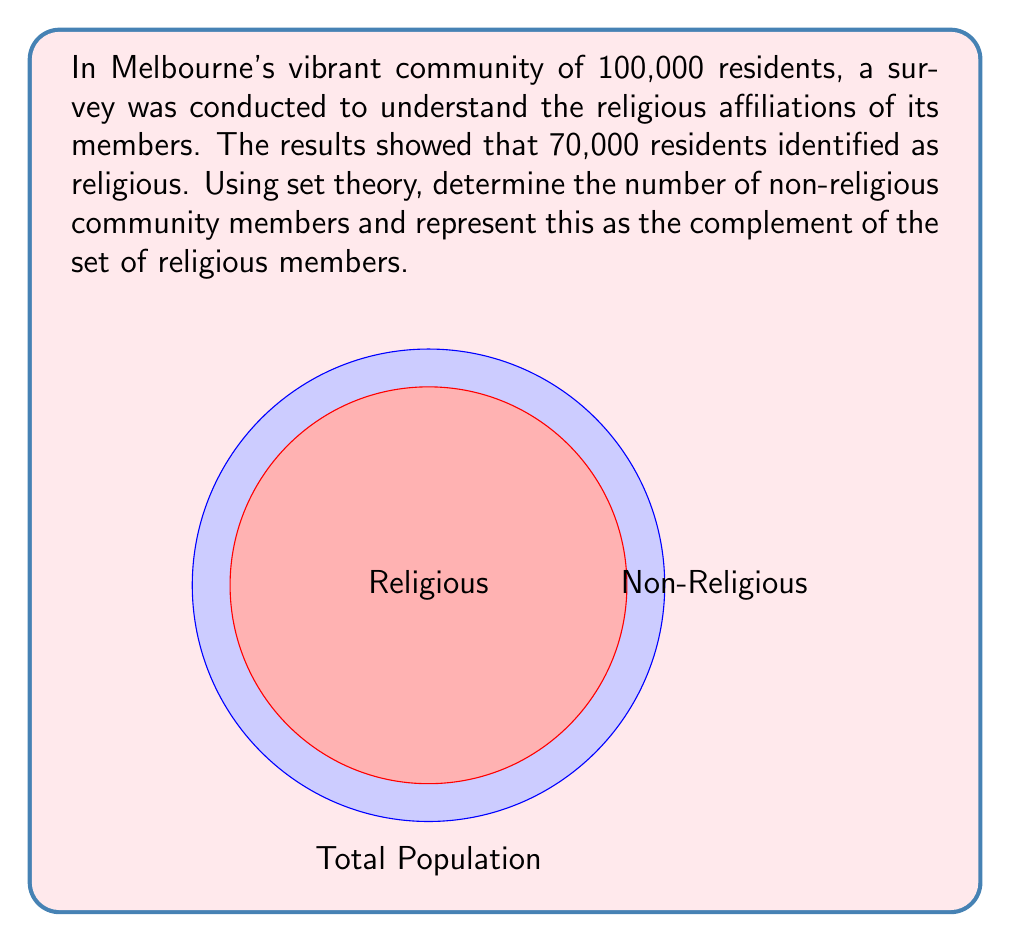Teach me how to tackle this problem. Let's approach this step-by-step using set theory:

1) Define the universal set $U$ as the total population of Melbourne:
   $U = 100,000$

2) Let $R$ be the set of religious community members:
   $|R| = 70,000$

3) We need to find the complement of $R$, denoted as $R^c$, which represents the non-religious community members.

4) In set theory, the complement of a set $A$ is defined as all elements in the universal set $U$ that are not in $A$:
   $A^c = U \setminus A$

5) The number of elements in the complement can be calculated by subtracting the number of elements in the set from the total number of elements in the universal set:
   $|R^c| = |U| - |R|$

6) Substituting the values:
   $|R^c| = 100,000 - 70,000 = 30,000$

Therefore, the number of non-religious community members is 30,000.
Answer: $|R^c| = 30,000$ 